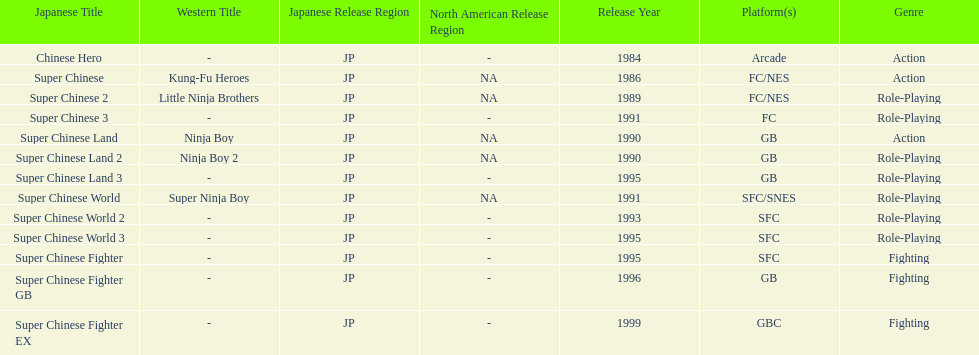How many action games were released in north america? 2. 